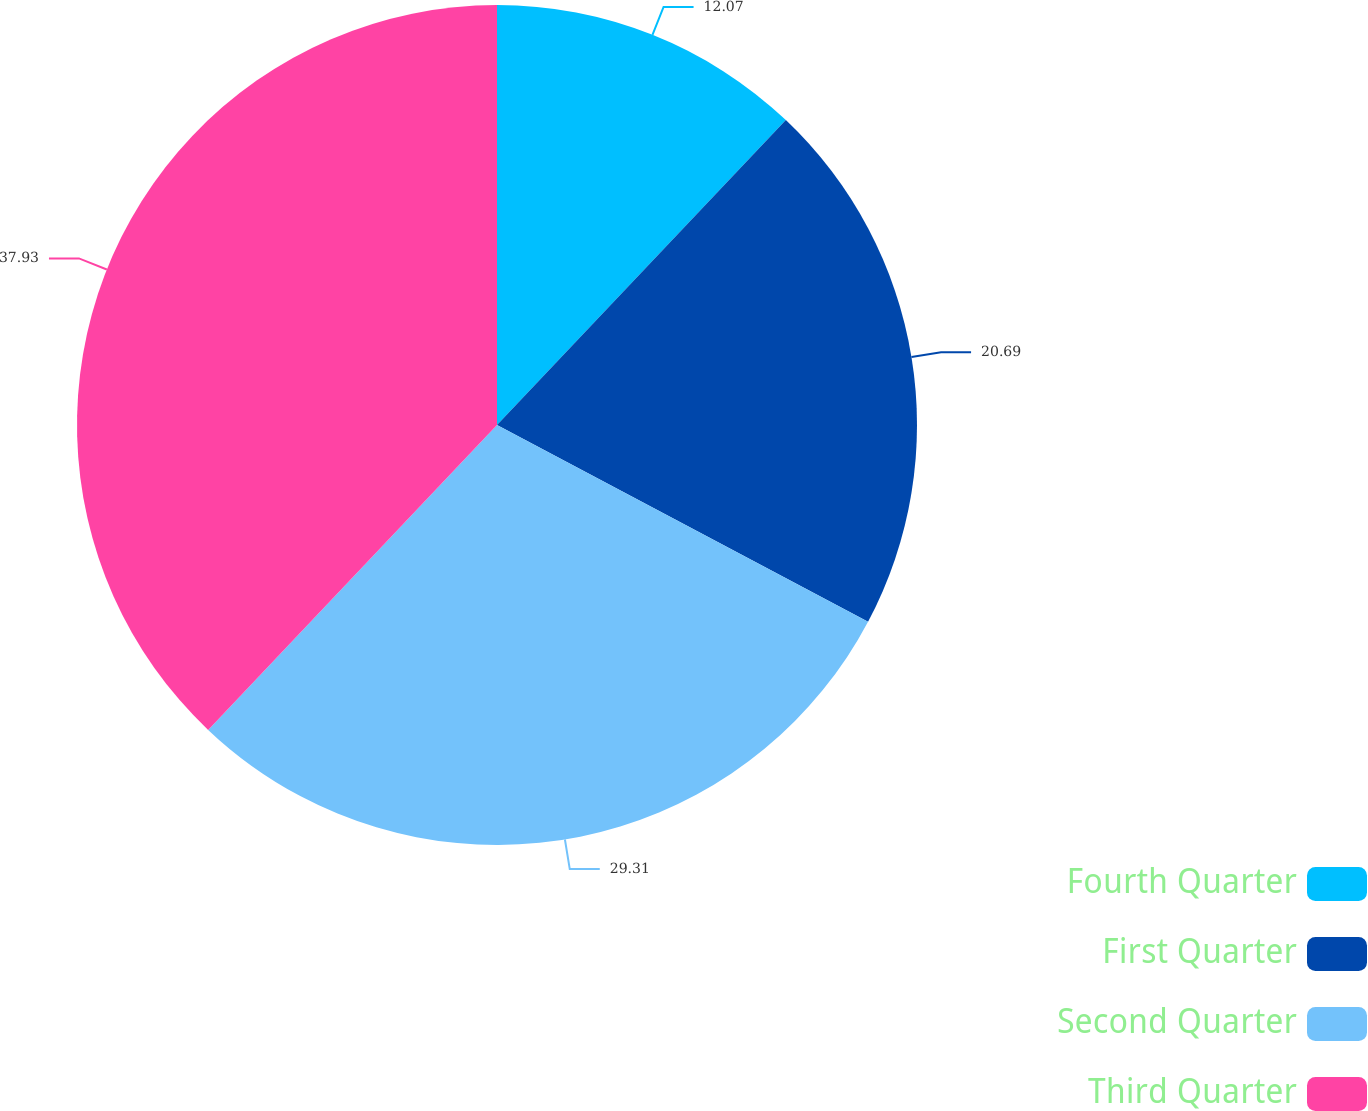<chart> <loc_0><loc_0><loc_500><loc_500><pie_chart><fcel>Fourth Quarter<fcel>First Quarter<fcel>Second Quarter<fcel>Third Quarter<nl><fcel>12.07%<fcel>20.69%<fcel>29.31%<fcel>37.93%<nl></chart> 